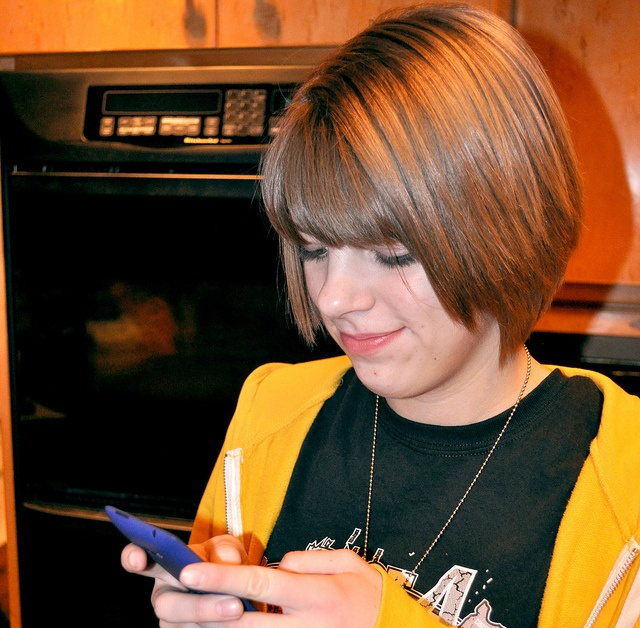Describe the objects in this image and their specific colors. I can see people in orange, black, lightpink, and gray tones, oven in orange, black, maroon, and brown tones, and cell phone in orange, navy, blue, and purple tones in this image. 